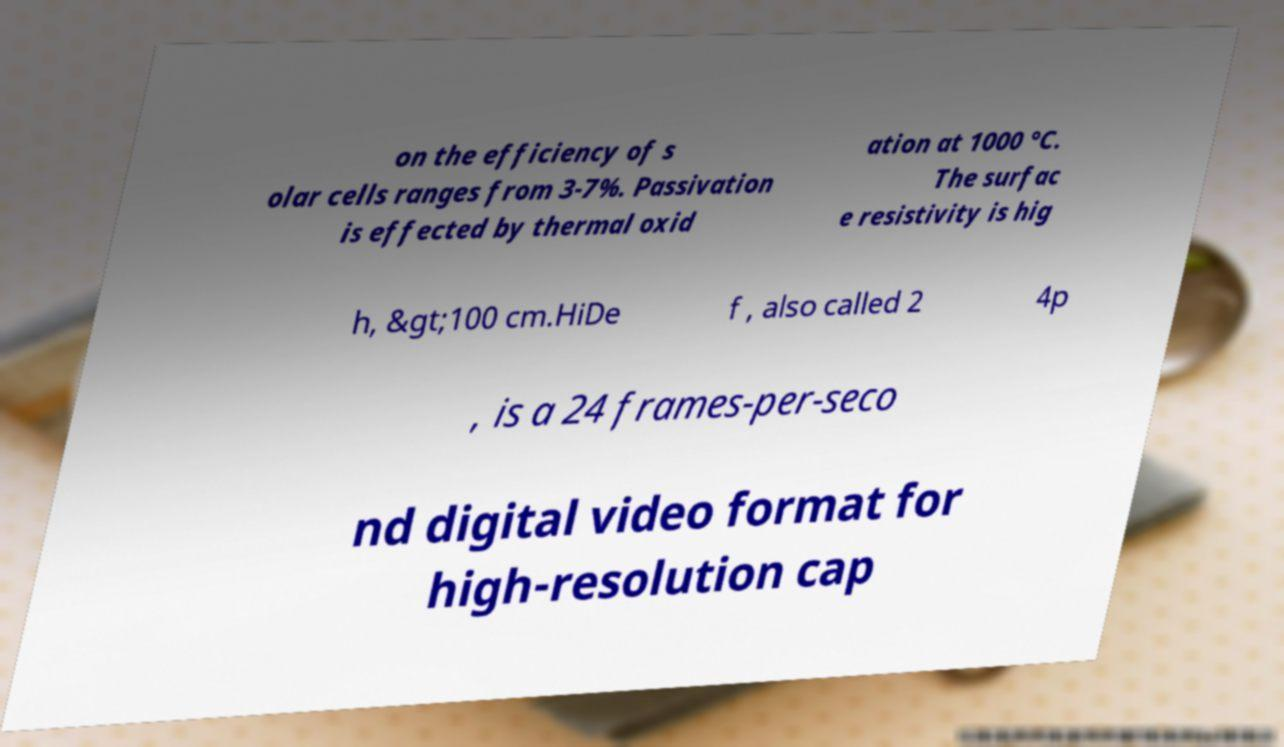There's text embedded in this image that I need extracted. Can you transcribe it verbatim? on the efficiency of s olar cells ranges from 3-7%. Passivation is effected by thermal oxid ation at 1000 °C. The surfac e resistivity is hig h, &gt;100 cm.HiDe f , also called 2 4p , is a 24 frames-per-seco nd digital video format for high-resolution cap 